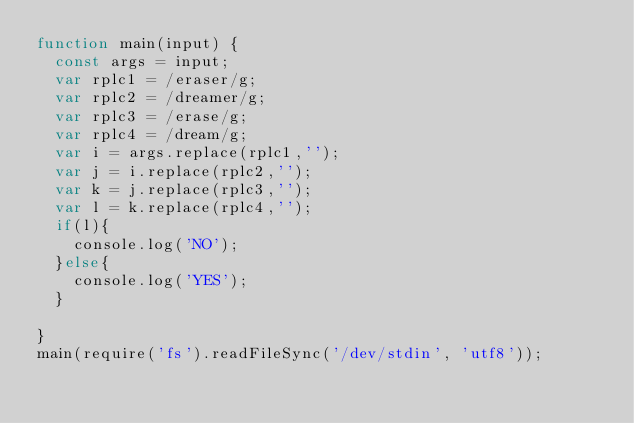<code> <loc_0><loc_0><loc_500><loc_500><_JavaScript_>function main(input) {
  const args = input;
  var rplc1 = /eraser/g;
  var rplc2 = /dreamer/g;
  var rplc3 = /erase/g;
  var rplc4 = /dream/g;
  var i = args.replace(rplc1,'');
  var j = i.replace(rplc2,'');
  var k = j.replace(rplc3,'');
  var l = k.replace(rplc4,'');
  if(l){
    console.log('NO');
  }else{
    console.log('YES');
  }
  
}
main(require('fs').readFileSync('/dev/stdin', 'utf8'));</code> 